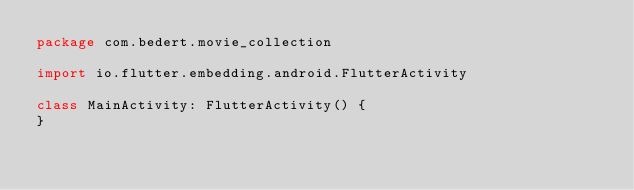Convert code to text. <code><loc_0><loc_0><loc_500><loc_500><_Kotlin_>package com.bedert.movie_collection

import io.flutter.embedding.android.FlutterActivity

class MainActivity: FlutterActivity() {
}
</code> 